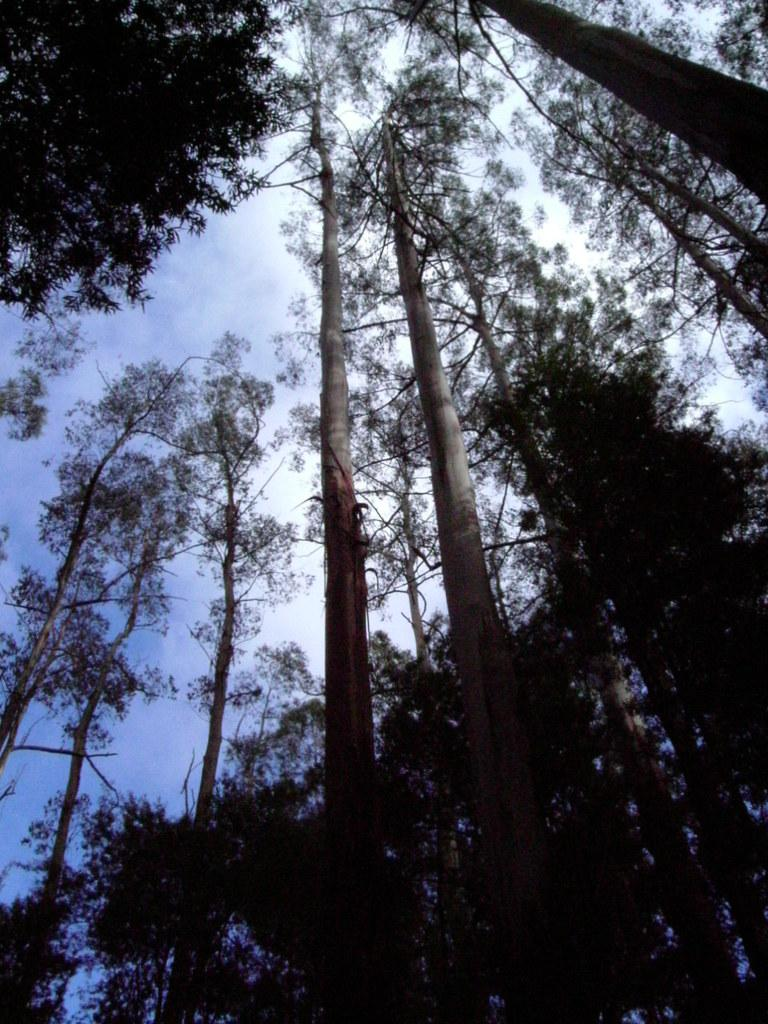What type of vegetation can be seen in the image? There are tall trees in the image. How would you describe the sky in the image? The sky is blue and cloudy in the image. What type of bird can be seen flying in the image? There are no birds visible in the image; it only features tall trees and a blue, cloudy sky. Is there any popcorn present in the image? There is no popcorn present in the image. 